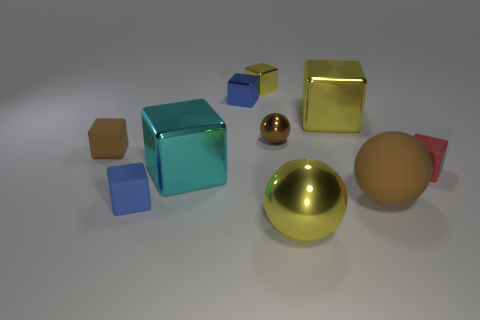Subtract all red rubber cubes. How many cubes are left? 6 Subtract all red cylinders. How many yellow blocks are left? 2 Subtract all brown blocks. How many blocks are left? 6 Subtract 3 balls. How many balls are left? 0 Subtract all purple balls. Subtract all blue blocks. How many balls are left? 3 Subtract all balls. How many objects are left? 7 Subtract all small blue rubber cubes. Subtract all brown metallic spheres. How many objects are left? 8 Add 7 big brown rubber things. How many big brown rubber things are left? 8 Add 9 blue metal things. How many blue metal things exist? 10 Subtract 0 red balls. How many objects are left? 10 